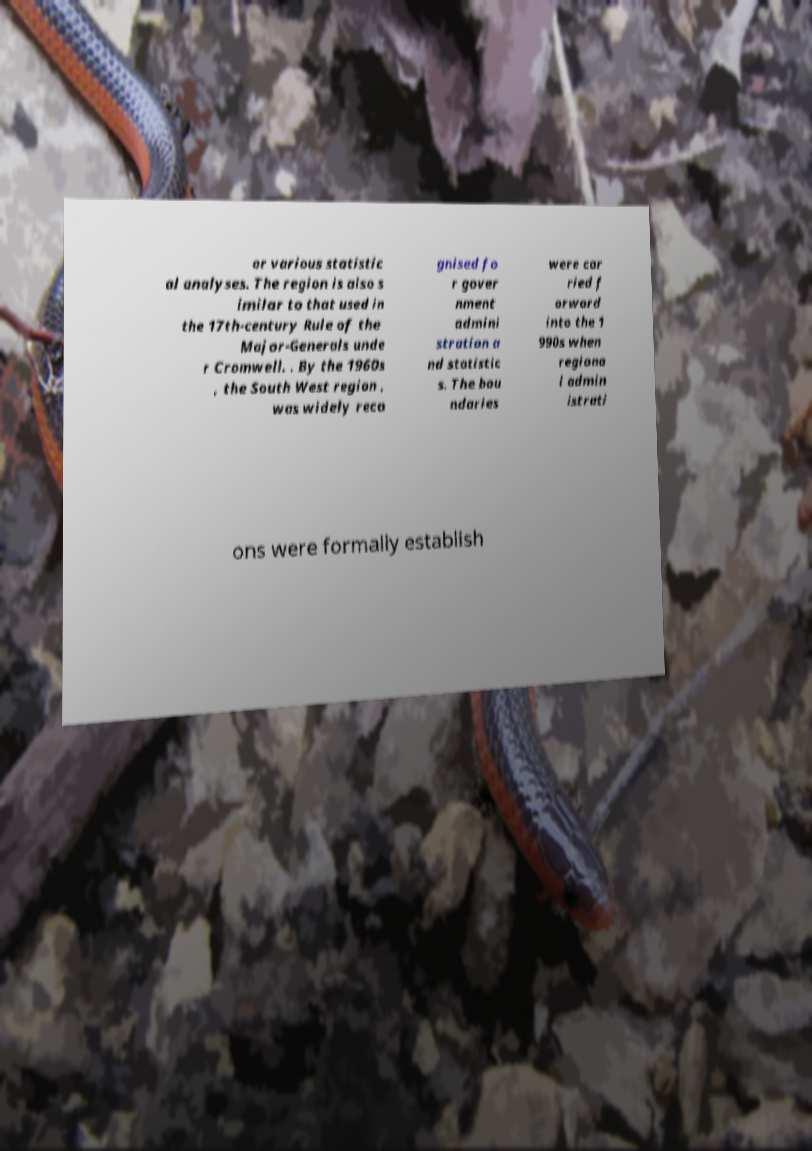Please identify and transcribe the text found in this image. or various statistic al analyses. The region is also s imilar to that used in the 17th-century Rule of the Major-Generals unde r Cromwell. . By the 1960s , the South West region , was widely reco gnised fo r gover nment admini stration a nd statistic s. The bou ndaries were car ried f orward into the 1 990s when regiona l admin istrati ons were formally establish 